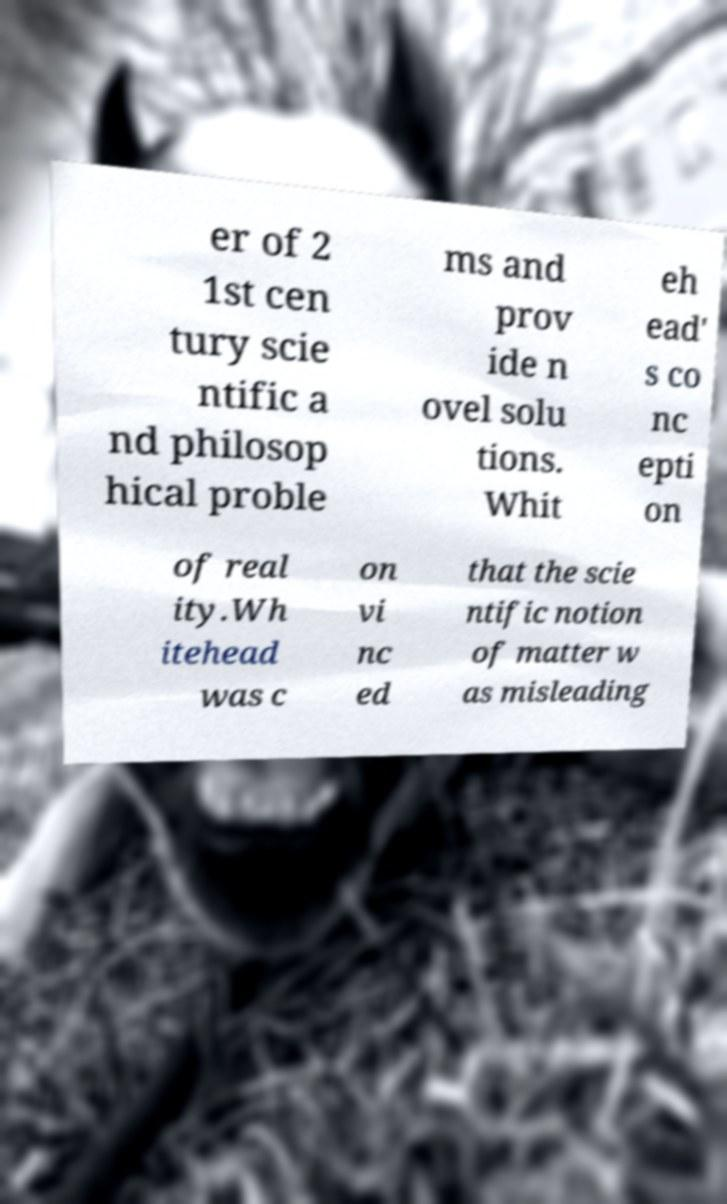Could you extract and type out the text from this image? er of 2 1st cen tury scie ntific a nd philosop hical proble ms and prov ide n ovel solu tions. Whit eh ead' s co nc epti on of real ity.Wh itehead was c on vi nc ed that the scie ntific notion of matter w as misleading 